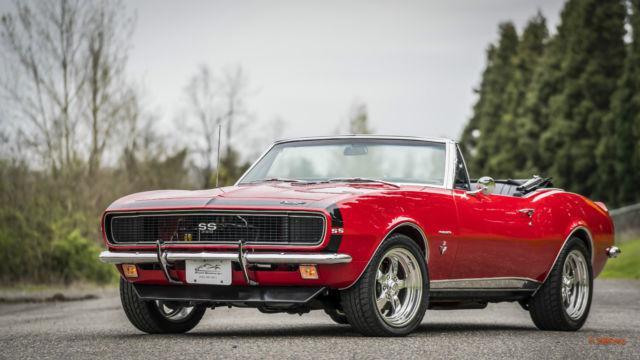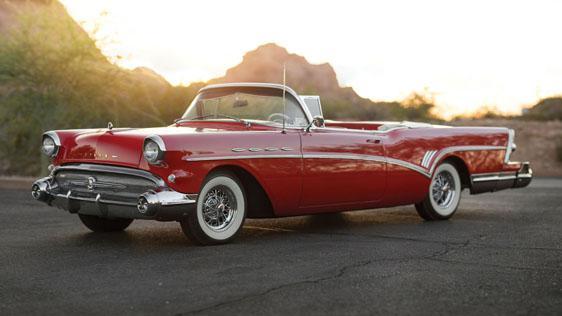The first image is the image on the left, the second image is the image on the right. Considering the images on both sides, is "In each image, the front grille of the car is visible." valid? Answer yes or no. Yes. 